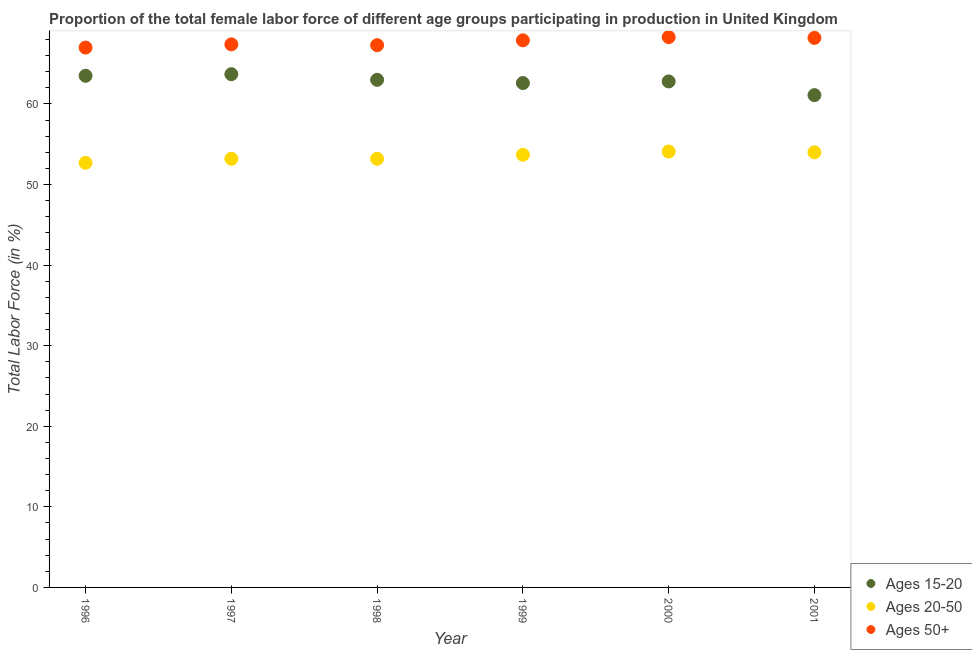Is the number of dotlines equal to the number of legend labels?
Your answer should be very brief. Yes. What is the percentage of female labor force within the age group 20-50 in 2000?
Your response must be concise. 54.1. Across all years, what is the maximum percentage of female labor force within the age group 20-50?
Offer a very short reply. 54.1. Across all years, what is the minimum percentage of female labor force within the age group 15-20?
Your answer should be compact. 61.1. What is the total percentage of female labor force within the age group 20-50 in the graph?
Provide a short and direct response. 320.9. What is the difference between the percentage of female labor force within the age group 20-50 in 2001 and the percentage of female labor force within the age group 15-20 in 1999?
Offer a terse response. -8.6. What is the average percentage of female labor force within the age group 20-50 per year?
Keep it short and to the point. 53.48. In the year 1997, what is the difference between the percentage of female labor force within the age group 15-20 and percentage of female labor force above age 50?
Keep it short and to the point. -3.7. In how many years, is the percentage of female labor force within the age group 20-50 greater than 42 %?
Provide a succinct answer. 6. What is the ratio of the percentage of female labor force within the age group 15-20 in 1996 to that in 1998?
Give a very brief answer. 1.01. Is the percentage of female labor force above age 50 in 1997 less than that in 2001?
Offer a very short reply. Yes. Is the difference between the percentage of female labor force within the age group 15-20 in 1998 and 1999 greater than the difference between the percentage of female labor force above age 50 in 1998 and 1999?
Your answer should be very brief. Yes. What is the difference between the highest and the second highest percentage of female labor force within the age group 20-50?
Ensure brevity in your answer.  0.1. What is the difference between the highest and the lowest percentage of female labor force above age 50?
Make the answer very short. 1.3. In how many years, is the percentage of female labor force within the age group 15-20 greater than the average percentage of female labor force within the age group 15-20 taken over all years?
Your response must be concise. 4. Is the sum of the percentage of female labor force above age 50 in 1996 and 1999 greater than the maximum percentage of female labor force within the age group 20-50 across all years?
Provide a succinct answer. Yes. Is it the case that in every year, the sum of the percentage of female labor force within the age group 15-20 and percentage of female labor force within the age group 20-50 is greater than the percentage of female labor force above age 50?
Your response must be concise. Yes. Does the percentage of female labor force above age 50 monotonically increase over the years?
Offer a very short reply. No. Is the percentage of female labor force within the age group 15-20 strictly greater than the percentage of female labor force above age 50 over the years?
Keep it short and to the point. No. Is the percentage of female labor force within the age group 15-20 strictly less than the percentage of female labor force above age 50 over the years?
Provide a succinct answer. Yes. How many dotlines are there?
Give a very brief answer. 3. How many years are there in the graph?
Keep it short and to the point. 6. Does the graph contain any zero values?
Make the answer very short. No. How many legend labels are there?
Give a very brief answer. 3. What is the title of the graph?
Your response must be concise. Proportion of the total female labor force of different age groups participating in production in United Kingdom. What is the label or title of the Y-axis?
Provide a short and direct response. Total Labor Force (in %). What is the Total Labor Force (in %) in Ages 15-20 in 1996?
Ensure brevity in your answer.  63.5. What is the Total Labor Force (in %) of Ages 20-50 in 1996?
Give a very brief answer. 52.7. What is the Total Labor Force (in %) in Ages 50+ in 1996?
Give a very brief answer. 67. What is the Total Labor Force (in %) in Ages 15-20 in 1997?
Give a very brief answer. 63.7. What is the Total Labor Force (in %) in Ages 20-50 in 1997?
Your answer should be compact. 53.2. What is the Total Labor Force (in %) in Ages 50+ in 1997?
Your answer should be very brief. 67.4. What is the Total Labor Force (in %) in Ages 15-20 in 1998?
Provide a short and direct response. 63. What is the Total Labor Force (in %) of Ages 20-50 in 1998?
Offer a terse response. 53.2. What is the Total Labor Force (in %) of Ages 50+ in 1998?
Your answer should be very brief. 67.3. What is the Total Labor Force (in %) in Ages 15-20 in 1999?
Provide a short and direct response. 62.6. What is the Total Labor Force (in %) of Ages 20-50 in 1999?
Ensure brevity in your answer.  53.7. What is the Total Labor Force (in %) in Ages 50+ in 1999?
Give a very brief answer. 67.9. What is the Total Labor Force (in %) in Ages 15-20 in 2000?
Your response must be concise. 62.8. What is the Total Labor Force (in %) in Ages 20-50 in 2000?
Provide a short and direct response. 54.1. What is the Total Labor Force (in %) in Ages 50+ in 2000?
Your answer should be very brief. 68.3. What is the Total Labor Force (in %) in Ages 15-20 in 2001?
Keep it short and to the point. 61.1. What is the Total Labor Force (in %) of Ages 50+ in 2001?
Keep it short and to the point. 68.2. Across all years, what is the maximum Total Labor Force (in %) of Ages 15-20?
Give a very brief answer. 63.7. Across all years, what is the maximum Total Labor Force (in %) in Ages 20-50?
Offer a very short reply. 54.1. Across all years, what is the maximum Total Labor Force (in %) in Ages 50+?
Offer a terse response. 68.3. Across all years, what is the minimum Total Labor Force (in %) in Ages 15-20?
Offer a terse response. 61.1. Across all years, what is the minimum Total Labor Force (in %) in Ages 20-50?
Your response must be concise. 52.7. What is the total Total Labor Force (in %) of Ages 15-20 in the graph?
Your answer should be compact. 376.7. What is the total Total Labor Force (in %) in Ages 20-50 in the graph?
Ensure brevity in your answer.  320.9. What is the total Total Labor Force (in %) in Ages 50+ in the graph?
Offer a terse response. 406.1. What is the difference between the Total Labor Force (in %) of Ages 15-20 in 1996 and that in 1997?
Keep it short and to the point. -0.2. What is the difference between the Total Labor Force (in %) in Ages 20-50 in 1996 and that in 1997?
Provide a succinct answer. -0.5. What is the difference between the Total Labor Force (in %) in Ages 50+ in 1996 and that in 1998?
Give a very brief answer. -0.3. What is the difference between the Total Labor Force (in %) of Ages 15-20 in 1996 and that in 1999?
Provide a short and direct response. 0.9. What is the difference between the Total Labor Force (in %) of Ages 20-50 in 1996 and that in 1999?
Keep it short and to the point. -1. What is the difference between the Total Labor Force (in %) of Ages 15-20 in 1996 and that in 2000?
Your answer should be compact. 0.7. What is the difference between the Total Labor Force (in %) of Ages 20-50 in 1996 and that in 2000?
Make the answer very short. -1.4. What is the difference between the Total Labor Force (in %) in Ages 50+ in 1996 and that in 2000?
Offer a very short reply. -1.3. What is the difference between the Total Labor Force (in %) in Ages 20-50 in 1996 and that in 2001?
Your answer should be compact. -1.3. What is the difference between the Total Labor Force (in %) in Ages 50+ in 1997 and that in 1998?
Your response must be concise. 0.1. What is the difference between the Total Labor Force (in %) of Ages 20-50 in 1997 and that in 1999?
Give a very brief answer. -0.5. What is the difference between the Total Labor Force (in %) in Ages 50+ in 1997 and that in 1999?
Ensure brevity in your answer.  -0.5. What is the difference between the Total Labor Force (in %) of Ages 20-50 in 1997 and that in 2000?
Give a very brief answer. -0.9. What is the difference between the Total Labor Force (in %) of Ages 50+ in 1997 and that in 2000?
Keep it short and to the point. -0.9. What is the difference between the Total Labor Force (in %) of Ages 20-50 in 1997 and that in 2001?
Offer a terse response. -0.8. What is the difference between the Total Labor Force (in %) of Ages 15-20 in 1998 and that in 1999?
Offer a very short reply. 0.4. What is the difference between the Total Labor Force (in %) of Ages 20-50 in 1998 and that in 1999?
Your answer should be very brief. -0.5. What is the difference between the Total Labor Force (in %) in Ages 15-20 in 1998 and that in 2000?
Make the answer very short. 0.2. What is the difference between the Total Labor Force (in %) in Ages 50+ in 1998 and that in 2001?
Provide a short and direct response. -0.9. What is the difference between the Total Labor Force (in %) of Ages 15-20 in 1999 and that in 2000?
Provide a short and direct response. -0.2. What is the difference between the Total Labor Force (in %) in Ages 20-50 in 1999 and that in 2001?
Provide a short and direct response. -0.3. What is the difference between the Total Labor Force (in %) of Ages 50+ in 1999 and that in 2001?
Your answer should be very brief. -0.3. What is the difference between the Total Labor Force (in %) of Ages 50+ in 2000 and that in 2001?
Give a very brief answer. 0.1. What is the difference between the Total Labor Force (in %) in Ages 15-20 in 1996 and the Total Labor Force (in %) in Ages 20-50 in 1997?
Make the answer very short. 10.3. What is the difference between the Total Labor Force (in %) of Ages 15-20 in 1996 and the Total Labor Force (in %) of Ages 50+ in 1997?
Offer a very short reply. -3.9. What is the difference between the Total Labor Force (in %) of Ages 20-50 in 1996 and the Total Labor Force (in %) of Ages 50+ in 1997?
Keep it short and to the point. -14.7. What is the difference between the Total Labor Force (in %) of Ages 15-20 in 1996 and the Total Labor Force (in %) of Ages 20-50 in 1998?
Keep it short and to the point. 10.3. What is the difference between the Total Labor Force (in %) in Ages 20-50 in 1996 and the Total Labor Force (in %) in Ages 50+ in 1998?
Your answer should be very brief. -14.6. What is the difference between the Total Labor Force (in %) of Ages 15-20 in 1996 and the Total Labor Force (in %) of Ages 20-50 in 1999?
Provide a succinct answer. 9.8. What is the difference between the Total Labor Force (in %) of Ages 15-20 in 1996 and the Total Labor Force (in %) of Ages 50+ in 1999?
Keep it short and to the point. -4.4. What is the difference between the Total Labor Force (in %) in Ages 20-50 in 1996 and the Total Labor Force (in %) in Ages 50+ in 1999?
Ensure brevity in your answer.  -15.2. What is the difference between the Total Labor Force (in %) in Ages 15-20 in 1996 and the Total Labor Force (in %) in Ages 20-50 in 2000?
Provide a short and direct response. 9.4. What is the difference between the Total Labor Force (in %) in Ages 15-20 in 1996 and the Total Labor Force (in %) in Ages 50+ in 2000?
Offer a terse response. -4.8. What is the difference between the Total Labor Force (in %) in Ages 20-50 in 1996 and the Total Labor Force (in %) in Ages 50+ in 2000?
Your response must be concise. -15.6. What is the difference between the Total Labor Force (in %) in Ages 15-20 in 1996 and the Total Labor Force (in %) in Ages 20-50 in 2001?
Make the answer very short. 9.5. What is the difference between the Total Labor Force (in %) of Ages 20-50 in 1996 and the Total Labor Force (in %) of Ages 50+ in 2001?
Keep it short and to the point. -15.5. What is the difference between the Total Labor Force (in %) in Ages 15-20 in 1997 and the Total Labor Force (in %) in Ages 20-50 in 1998?
Your answer should be compact. 10.5. What is the difference between the Total Labor Force (in %) of Ages 15-20 in 1997 and the Total Labor Force (in %) of Ages 50+ in 1998?
Your response must be concise. -3.6. What is the difference between the Total Labor Force (in %) of Ages 20-50 in 1997 and the Total Labor Force (in %) of Ages 50+ in 1998?
Offer a very short reply. -14.1. What is the difference between the Total Labor Force (in %) in Ages 20-50 in 1997 and the Total Labor Force (in %) in Ages 50+ in 1999?
Provide a short and direct response. -14.7. What is the difference between the Total Labor Force (in %) in Ages 20-50 in 1997 and the Total Labor Force (in %) in Ages 50+ in 2000?
Offer a terse response. -15.1. What is the difference between the Total Labor Force (in %) in Ages 15-20 in 1997 and the Total Labor Force (in %) in Ages 20-50 in 2001?
Provide a succinct answer. 9.7. What is the difference between the Total Labor Force (in %) of Ages 15-20 in 1998 and the Total Labor Force (in %) of Ages 20-50 in 1999?
Your answer should be very brief. 9.3. What is the difference between the Total Labor Force (in %) in Ages 20-50 in 1998 and the Total Labor Force (in %) in Ages 50+ in 1999?
Provide a succinct answer. -14.7. What is the difference between the Total Labor Force (in %) of Ages 15-20 in 1998 and the Total Labor Force (in %) of Ages 20-50 in 2000?
Make the answer very short. 8.9. What is the difference between the Total Labor Force (in %) of Ages 20-50 in 1998 and the Total Labor Force (in %) of Ages 50+ in 2000?
Your answer should be compact. -15.1. What is the difference between the Total Labor Force (in %) in Ages 15-20 in 1998 and the Total Labor Force (in %) in Ages 50+ in 2001?
Your response must be concise. -5.2. What is the difference between the Total Labor Force (in %) in Ages 20-50 in 1998 and the Total Labor Force (in %) in Ages 50+ in 2001?
Ensure brevity in your answer.  -15. What is the difference between the Total Labor Force (in %) of Ages 15-20 in 1999 and the Total Labor Force (in %) of Ages 50+ in 2000?
Provide a succinct answer. -5.7. What is the difference between the Total Labor Force (in %) in Ages 20-50 in 1999 and the Total Labor Force (in %) in Ages 50+ in 2000?
Offer a very short reply. -14.6. What is the difference between the Total Labor Force (in %) in Ages 15-20 in 1999 and the Total Labor Force (in %) in Ages 20-50 in 2001?
Keep it short and to the point. 8.6. What is the difference between the Total Labor Force (in %) of Ages 15-20 in 2000 and the Total Labor Force (in %) of Ages 20-50 in 2001?
Provide a short and direct response. 8.8. What is the difference between the Total Labor Force (in %) in Ages 15-20 in 2000 and the Total Labor Force (in %) in Ages 50+ in 2001?
Provide a short and direct response. -5.4. What is the difference between the Total Labor Force (in %) in Ages 20-50 in 2000 and the Total Labor Force (in %) in Ages 50+ in 2001?
Your answer should be very brief. -14.1. What is the average Total Labor Force (in %) in Ages 15-20 per year?
Give a very brief answer. 62.78. What is the average Total Labor Force (in %) of Ages 20-50 per year?
Keep it short and to the point. 53.48. What is the average Total Labor Force (in %) in Ages 50+ per year?
Keep it short and to the point. 67.68. In the year 1996, what is the difference between the Total Labor Force (in %) of Ages 15-20 and Total Labor Force (in %) of Ages 50+?
Your answer should be compact. -3.5. In the year 1996, what is the difference between the Total Labor Force (in %) in Ages 20-50 and Total Labor Force (in %) in Ages 50+?
Offer a terse response. -14.3. In the year 1997, what is the difference between the Total Labor Force (in %) in Ages 15-20 and Total Labor Force (in %) in Ages 20-50?
Your response must be concise. 10.5. In the year 1997, what is the difference between the Total Labor Force (in %) in Ages 15-20 and Total Labor Force (in %) in Ages 50+?
Offer a terse response. -3.7. In the year 1997, what is the difference between the Total Labor Force (in %) in Ages 20-50 and Total Labor Force (in %) in Ages 50+?
Your answer should be compact. -14.2. In the year 1998, what is the difference between the Total Labor Force (in %) of Ages 15-20 and Total Labor Force (in %) of Ages 20-50?
Provide a short and direct response. 9.8. In the year 1998, what is the difference between the Total Labor Force (in %) in Ages 15-20 and Total Labor Force (in %) in Ages 50+?
Ensure brevity in your answer.  -4.3. In the year 1998, what is the difference between the Total Labor Force (in %) of Ages 20-50 and Total Labor Force (in %) of Ages 50+?
Keep it short and to the point. -14.1. In the year 1999, what is the difference between the Total Labor Force (in %) in Ages 15-20 and Total Labor Force (in %) in Ages 20-50?
Make the answer very short. 8.9. In the year 1999, what is the difference between the Total Labor Force (in %) of Ages 15-20 and Total Labor Force (in %) of Ages 50+?
Your response must be concise. -5.3. In the year 2000, what is the difference between the Total Labor Force (in %) in Ages 15-20 and Total Labor Force (in %) in Ages 20-50?
Provide a succinct answer. 8.7. In the year 2000, what is the difference between the Total Labor Force (in %) in Ages 20-50 and Total Labor Force (in %) in Ages 50+?
Make the answer very short. -14.2. In the year 2001, what is the difference between the Total Labor Force (in %) of Ages 15-20 and Total Labor Force (in %) of Ages 50+?
Keep it short and to the point. -7.1. In the year 2001, what is the difference between the Total Labor Force (in %) of Ages 20-50 and Total Labor Force (in %) of Ages 50+?
Provide a short and direct response. -14.2. What is the ratio of the Total Labor Force (in %) in Ages 20-50 in 1996 to that in 1997?
Make the answer very short. 0.99. What is the ratio of the Total Labor Force (in %) in Ages 50+ in 1996 to that in 1997?
Keep it short and to the point. 0.99. What is the ratio of the Total Labor Force (in %) in Ages 15-20 in 1996 to that in 1998?
Provide a succinct answer. 1.01. What is the ratio of the Total Labor Force (in %) in Ages 20-50 in 1996 to that in 1998?
Ensure brevity in your answer.  0.99. What is the ratio of the Total Labor Force (in %) of Ages 50+ in 1996 to that in 1998?
Provide a short and direct response. 1. What is the ratio of the Total Labor Force (in %) of Ages 15-20 in 1996 to that in 1999?
Your response must be concise. 1.01. What is the ratio of the Total Labor Force (in %) of Ages 20-50 in 1996 to that in 1999?
Ensure brevity in your answer.  0.98. What is the ratio of the Total Labor Force (in %) of Ages 50+ in 1996 to that in 1999?
Provide a succinct answer. 0.99. What is the ratio of the Total Labor Force (in %) in Ages 15-20 in 1996 to that in 2000?
Offer a very short reply. 1.01. What is the ratio of the Total Labor Force (in %) of Ages 20-50 in 1996 to that in 2000?
Your answer should be compact. 0.97. What is the ratio of the Total Labor Force (in %) in Ages 15-20 in 1996 to that in 2001?
Your response must be concise. 1.04. What is the ratio of the Total Labor Force (in %) of Ages 20-50 in 1996 to that in 2001?
Ensure brevity in your answer.  0.98. What is the ratio of the Total Labor Force (in %) in Ages 50+ in 1996 to that in 2001?
Ensure brevity in your answer.  0.98. What is the ratio of the Total Labor Force (in %) of Ages 15-20 in 1997 to that in 1998?
Offer a terse response. 1.01. What is the ratio of the Total Labor Force (in %) in Ages 20-50 in 1997 to that in 1998?
Your answer should be very brief. 1. What is the ratio of the Total Labor Force (in %) of Ages 15-20 in 1997 to that in 1999?
Offer a terse response. 1.02. What is the ratio of the Total Labor Force (in %) of Ages 20-50 in 1997 to that in 1999?
Keep it short and to the point. 0.99. What is the ratio of the Total Labor Force (in %) of Ages 15-20 in 1997 to that in 2000?
Provide a short and direct response. 1.01. What is the ratio of the Total Labor Force (in %) of Ages 20-50 in 1997 to that in 2000?
Your answer should be very brief. 0.98. What is the ratio of the Total Labor Force (in %) in Ages 15-20 in 1997 to that in 2001?
Your response must be concise. 1.04. What is the ratio of the Total Labor Force (in %) of Ages 20-50 in 1997 to that in 2001?
Ensure brevity in your answer.  0.99. What is the ratio of the Total Labor Force (in %) in Ages 50+ in 1997 to that in 2001?
Offer a terse response. 0.99. What is the ratio of the Total Labor Force (in %) in Ages 15-20 in 1998 to that in 1999?
Your response must be concise. 1.01. What is the ratio of the Total Labor Force (in %) in Ages 20-50 in 1998 to that in 1999?
Ensure brevity in your answer.  0.99. What is the ratio of the Total Labor Force (in %) of Ages 20-50 in 1998 to that in 2000?
Ensure brevity in your answer.  0.98. What is the ratio of the Total Labor Force (in %) of Ages 50+ in 1998 to that in 2000?
Provide a short and direct response. 0.99. What is the ratio of the Total Labor Force (in %) in Ages 15-20 in 1998 to that in 2001?
Provide a succinct answer. 1.03. What is the ratio of the Total Labor Force (in %) in Ages 20-50 in 1998 to that in 2001?
Make the answer very short. 0.99. What is the ratio of the Total Labor Force (in %) in Ages 50+ in 1998 to that in 2001?
Provide a short and direct response. 0.99. What is the ratio of the Total Labor Force (in %) in Ages 15-20 in 1999 to that in 2001?
Keep it short and to the point. 1.02. What is the ratio of the Total Labor Force (in %) in Ages 50+ in 1999 to that in 2001?
Offer a terse response. 1. What is the ratio of the Total Labor Force (in %) in Ages 15-20 in 2000 to that in 2001?
Provide a short and direct response. 1.03. What is the ratio of the Total Labor Force (in %) in Ages 50+ in 2000 to that in 2001?
Offer a very short reply. 1. What is the difference between the highest and the second highest Total Labor Force (in %) of Ages 15-20?
Provide a succinct answer. 0.2. What is the difference between the highest and the second highest Total Labor Force (in %) in Ages 20-50?
Provide a short and direct response. 0.1. What is the difference between the highest and the second highest Total Labor Force (in %) in Ages 50+?
Make the answer very short. 0.1. What is the difference between the highest and the lowest Total Labor Force (in %) of Ages 20-50?
Offer a very short reply. 1.4. 